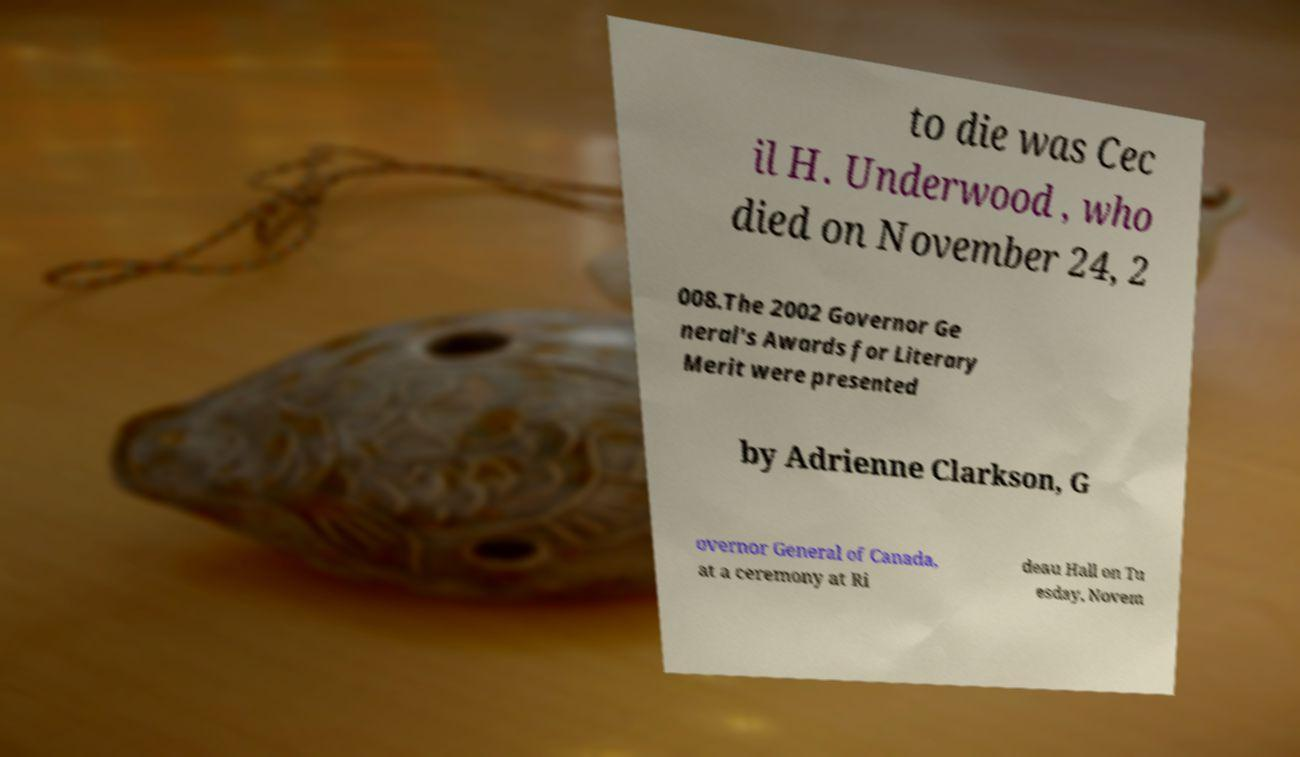Please read and relay the text visible in this image. What does it say? to die was Cec il H. Underwood , who died on November 24, 2 008.The 2002 Governor Ge neral's Awards for Literary Merit were presented by Adrienne Clarkson, G overnor General of Canada, at a ceremony at Ri deau Hall on Tu esday, Novem 